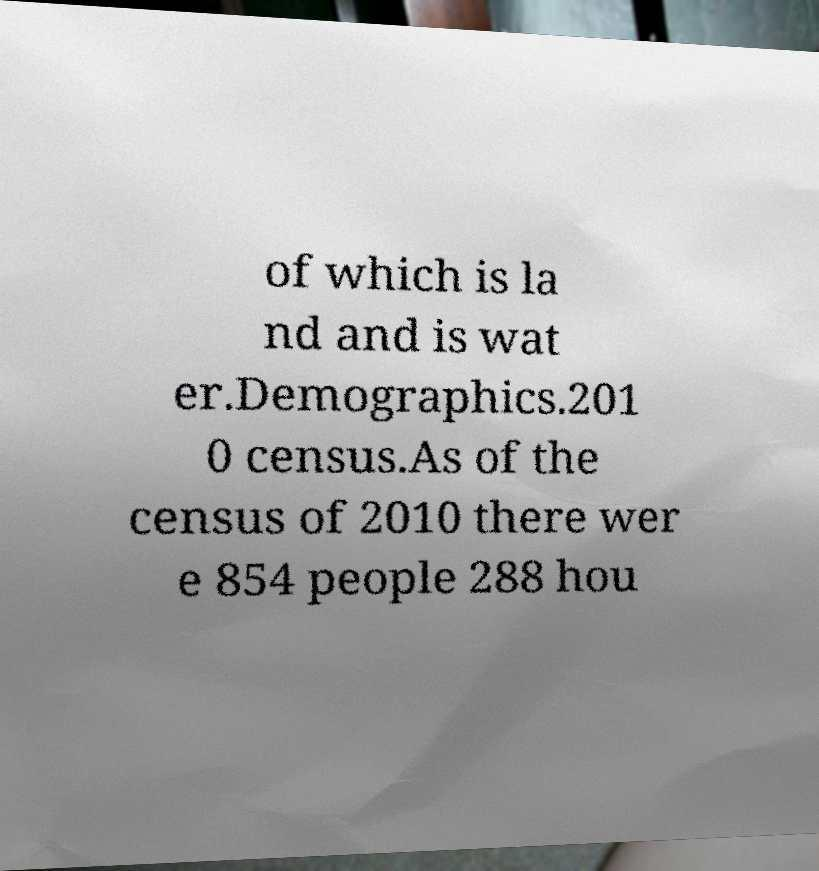I need the written content from this picture converted into text. Can you do that? of which is la nd and is wat er.Demographics.201 0 census.As of the census of 2010 there wer e 854 people 288 hou 